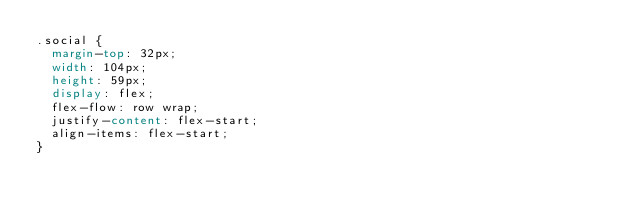Convert code to text. <code><loc_0><loc_0><loc_500><loc_500><_CSS_>.social {
  margin-top: 32px;
  width: 104px;
  height: 59px;
  display: flex;
  flex-flow: row wrap;
  justify-content: flex-start;
  align-items: flex-start;
}</code> 